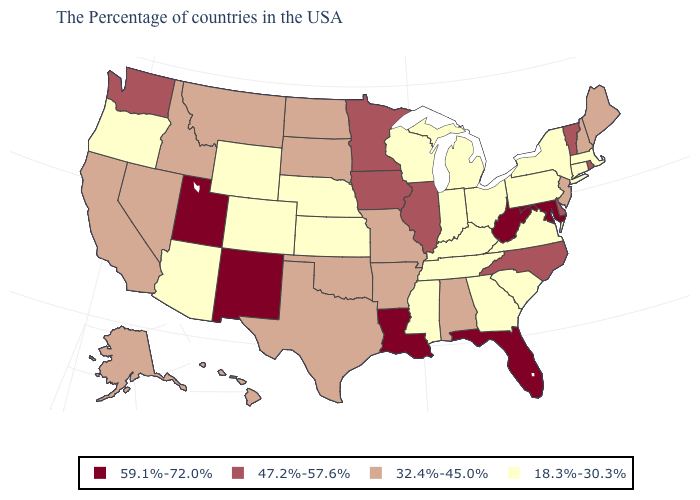Is the legend a continuous bar?
Short answer required. No. What is the value of Delaware?
Concise answer only. 47.2%-57.6%. What is the value of Connecticut?
Short answer required. 18.3%-30.3%. Does Arizona have the lowest value in the USA?
Short answer required. Yes. Name the states that have a value in the range 32.4%-45.0%?
Quick response, please. Maine, New Hampshire, New Jersey, Alabama, Missouri, Arkansas, Oklahoma, Texas, South Dakota, North Dakota, Montana, Idaho, Nevada, California, Alaska, Hawaii. Name the states that have a value in the range 47.2%-57.6%?
Be succinct. Rhode Island, Vermont, Delaware, North Carolina, Illinois, Minnesota, Iowa, Washington. Which states have the lowest value in the USA?
Write a very short answer. Massachusetts, Connecticut, New York, Pennsylvania, Virginia, South Carolina, Ohio, Georgia, Michigan, Kentucky, Indiana, Tennessee, Wisconsin, Mississippi, Kansas, Nebraska, Wyoming, Colorado, Arizona, Oregon. Which states have the lowest value in the West?
Write a very short answer. Wyoming, Colorado, Arizona, Oregon. What is the value of Oregon?
Answer briefly. 18.3%-30.3%. What is the highest value in the USA?
Give a very brief answer. 59.1%-72.0%. What is the lowest value in the USA?
Keep it brief. 18.3%-30.3%. Name the states that have a value in the range 47.2%-57.6%?
Answer briefly. Rhode Island, Vermont, Delaware, North Carolina, Illinois, Minnesota, Iowa, Washington. What is the value of Nevada?
Quick response, please. 32.4%-45.0%. Does New York have the lowest value in the Northeast?
Answer briefly. Yes. What is the lowest value in the Northeast?
Keep it brief. 18.3%-30.3%. 